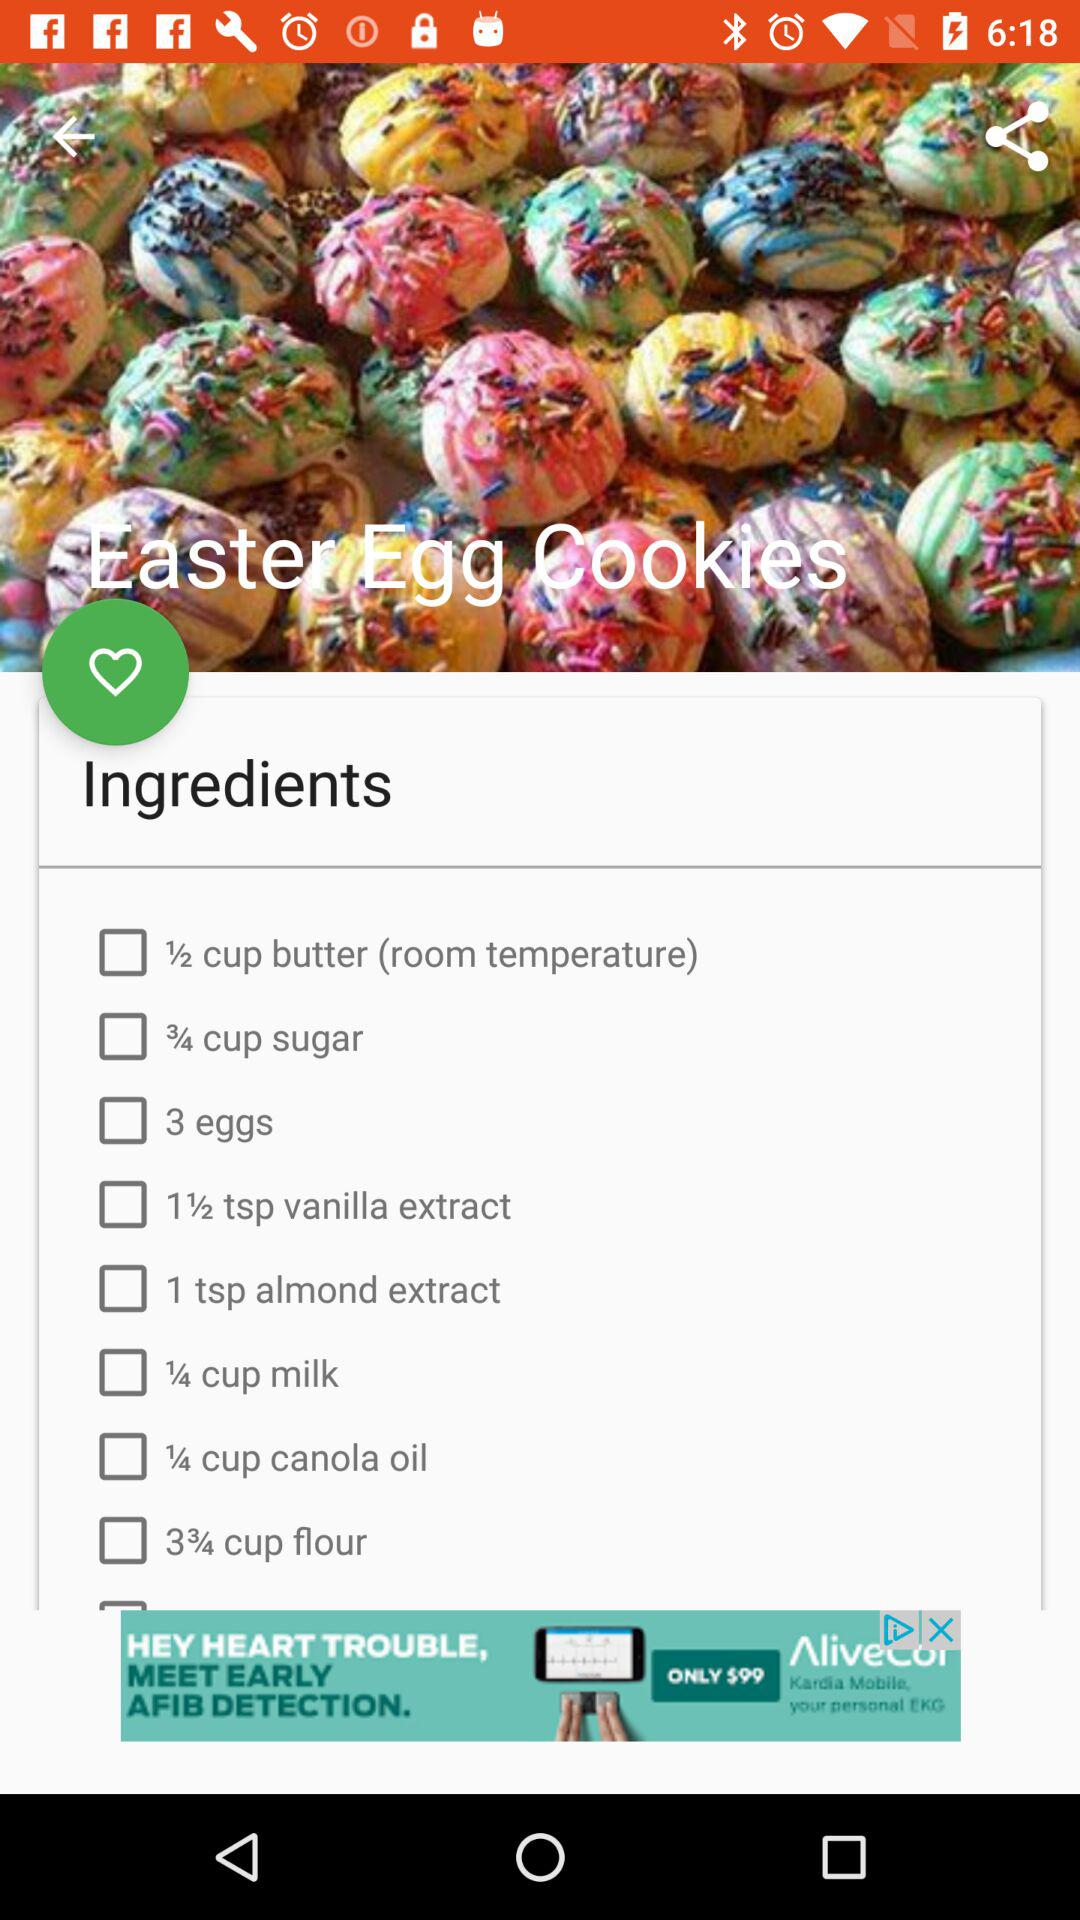What is the name of the dish? The name of the dish is "Easter Egg Cookies". 